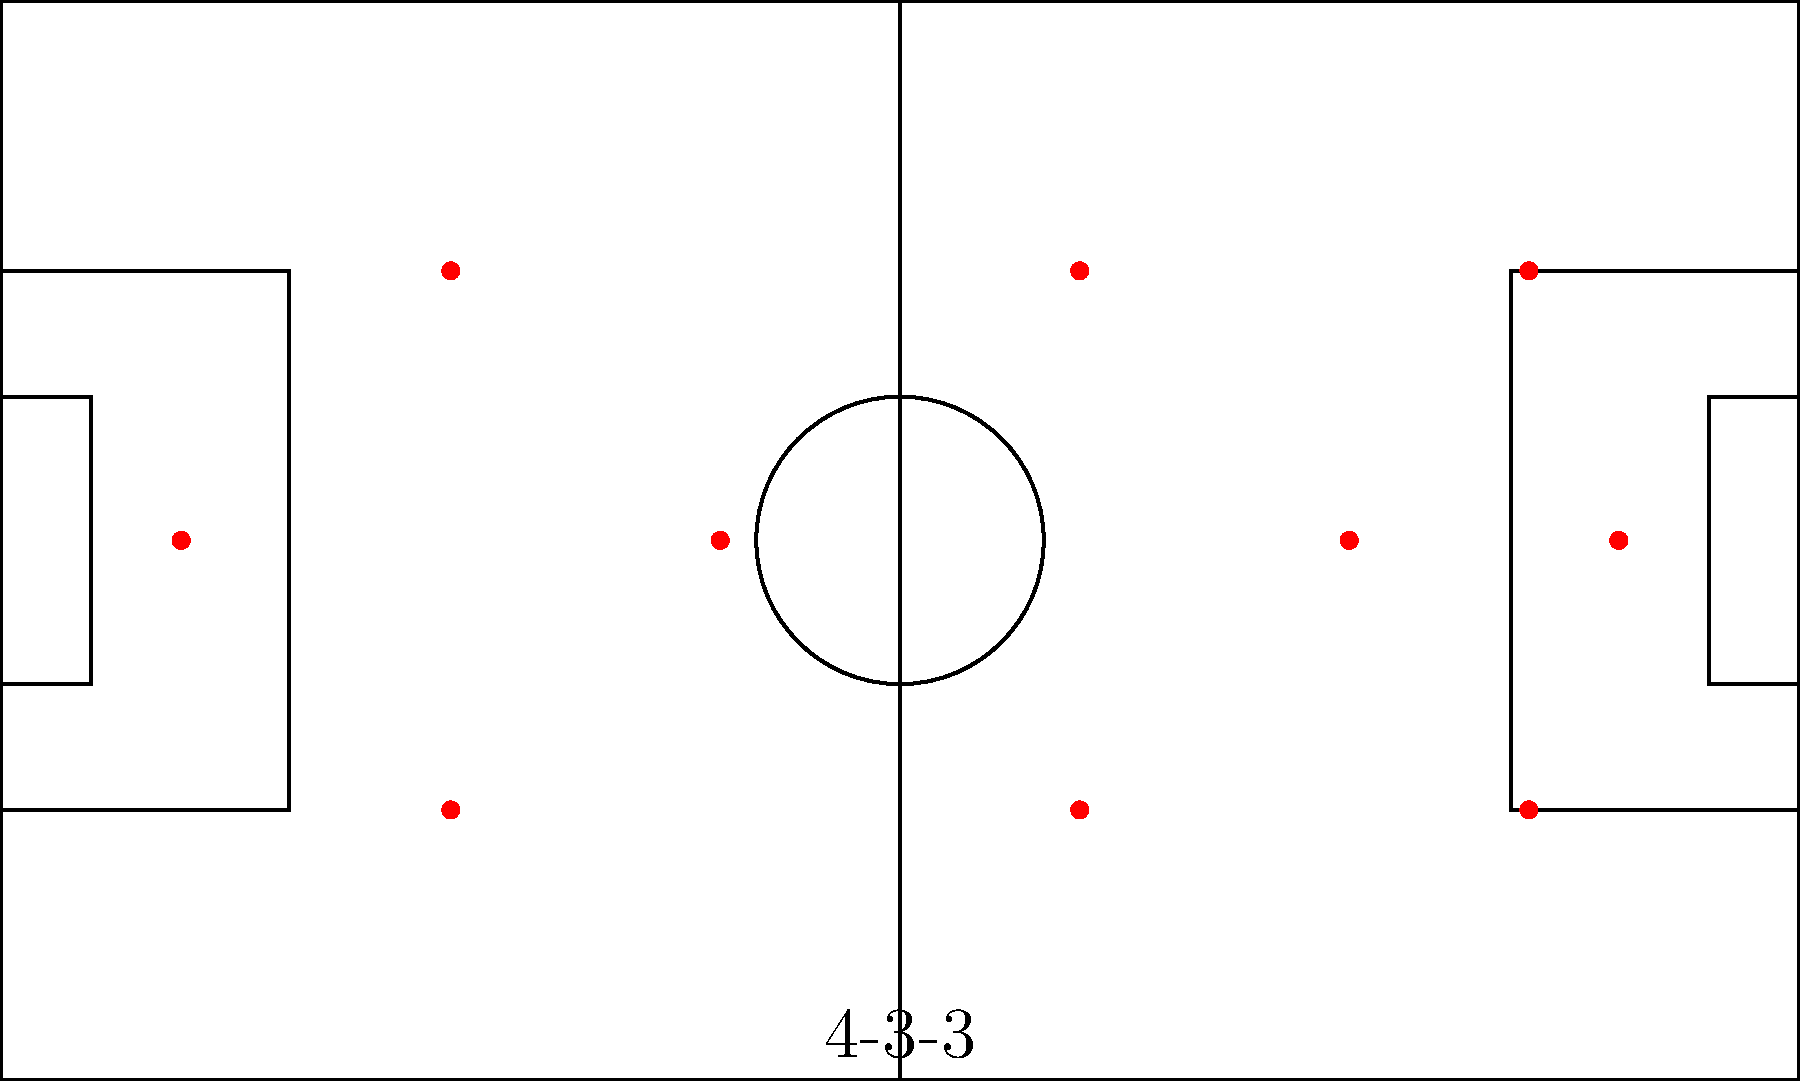As a coach analyzing team formation strategies, which tactical advantage does the 4-3-3 formation shown in the diagram provide in terms of player positioning and potential ball movement? To analyze the tactical advantage of the 4-3-3 formation shown in the diagram, let's break it down step-by-step:

1. Defensive line: The formation shows 4 defenders spread across the back, providing a solid defensive base.

2. Midfield: There are 3 midfielders positioned in a triangle, with one slightly behind the other two.

3. Forward line: 3 forwards are positioned high up the field, with a central striker and two wingers.

4. Width: The formation utilizes the full width of the field, with wingers positioned wide and fullbacks able to push forward.

5. Triangles: This formation creates multiple triangles across the field, facilitating passing options and player movement.

6. Pressing: With three forwards, the team can apply high pressure on the opponent's defense.

7. Counter-attacking: The wide positioning of forwards allows for quick transitions from defense to attack.

8. Flexibility: This formation can easily shift to a 4-5-1 in defensive situations or a 3-4-3 when attacking.

The main tactical advantage of this formation is its balance between defense and attack, while providing width and multiple passing options through the creation of triangles across the field. It allows for both possession-based play and quick counter-attacks, making it versatile against various opponent strategies.
Answer: Balanced attack and defense with width, pressing capabilities, and flexible transitions 